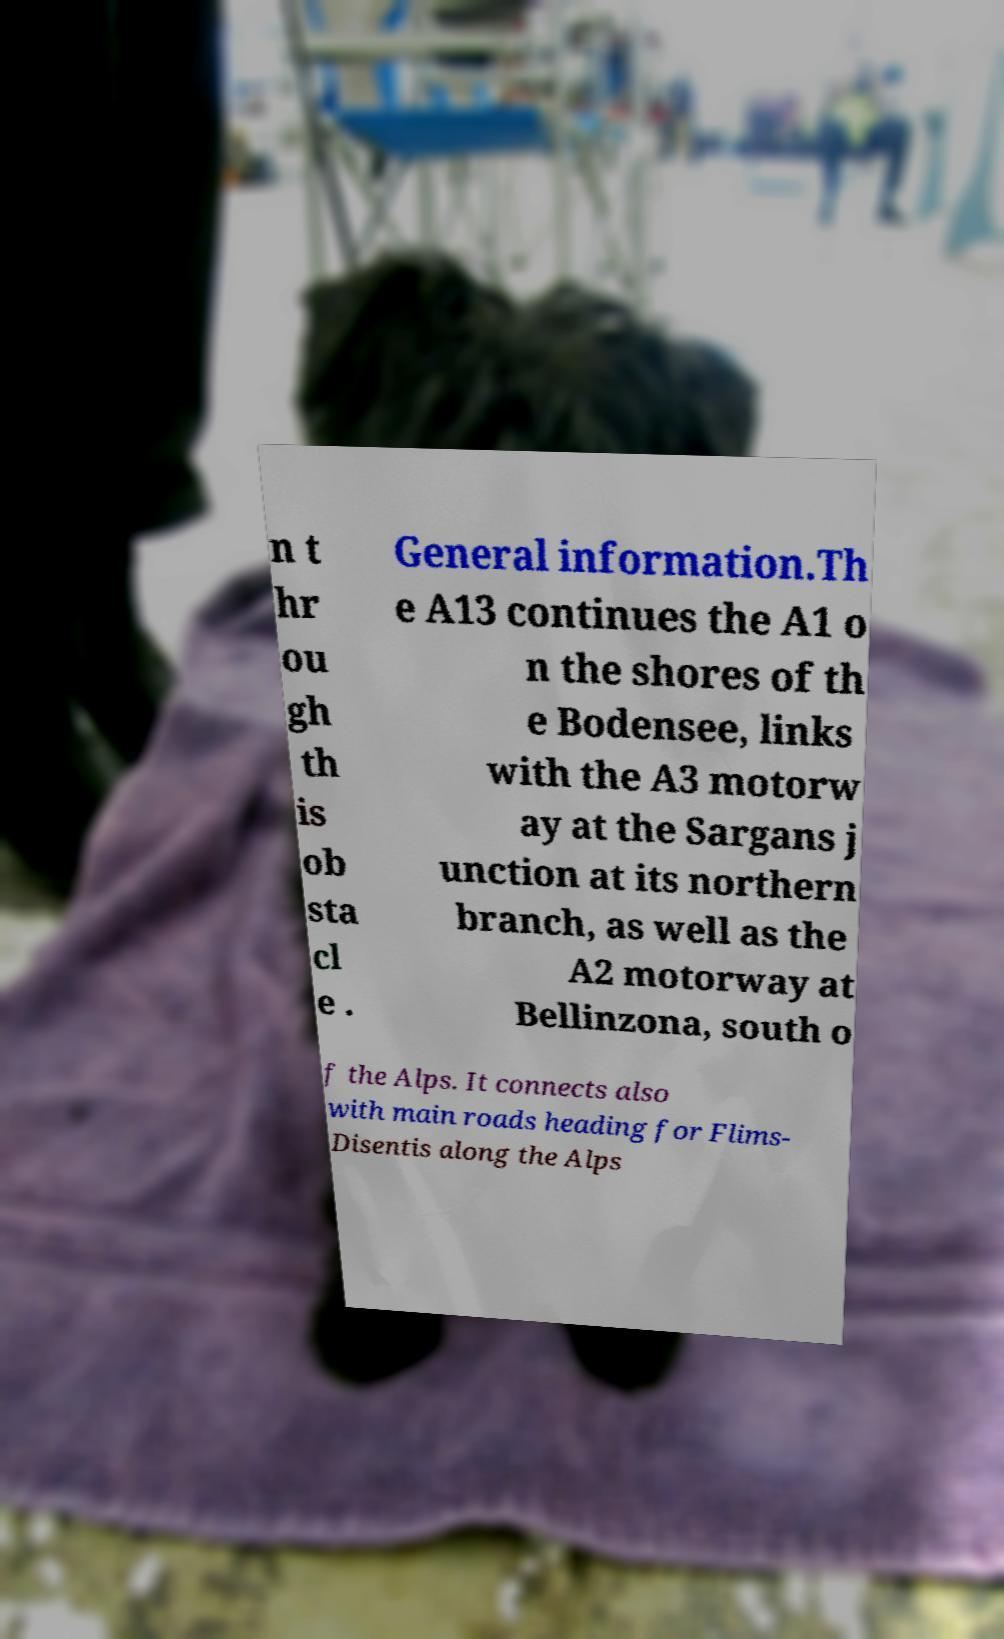What messages or text are displayed in this image? I need them in a readable, typed format. n t hr ou gh th is ob sta cl e . General information.Th e A13 continues the A1 o n the shores of th e Bodensee, links with the A3 motorw ay at the Sargans j unction at its northern branch, as well as the A2 motorway at Bellinzona, south o f the Alps. It connects also with main roads heading for Flims- Disentis along the Alps 